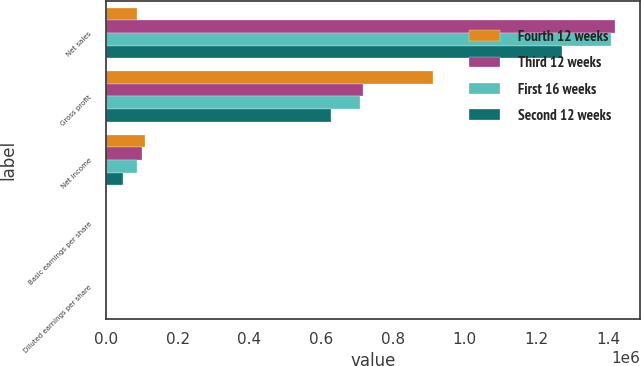Convert chart to OTSL. <chart><loc_0><loc_0><loc_500><loc_500><stacked_bar_chart><ecel><fcel>Net sales<fcel>Gross profit<fcel>Net income<fcel>Basic earnings per share<fcel>Diluted earnings per share<nl><fcel>Fourth 12 weeks<fcel>87598<fcel>910777<fcel>109431<fcel>1.2<fcel>1.19<nl><fcel>Third 12 weeks<fcel>1.41796e+06<fcel>715268<fcel>100911<fcel>1.18<fcel>1.16<nl><fcel>First 16 weeks<fcel>1.40651e+06<fcel>707785<fcel>87598<fcel>1.04<fcel>1.03<nl><fcel>Second 12 weeks<fcel>1.27013e+06<fcel>627485<fcel>48113<fcel>0.58<fcel>0.57<nl></chart> 